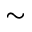Convert formula to latex. <formula><loc_0><loc_0><loc_500><loc_500>\sim</formula> 